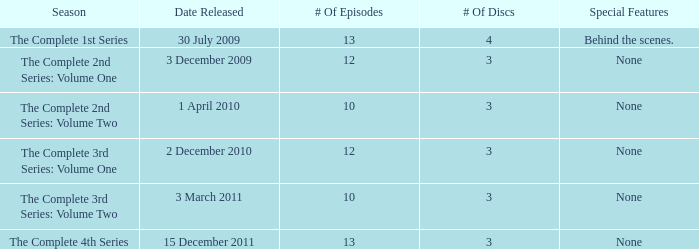On which day was the entire second series, volume one, made available? 3 December 2009. 